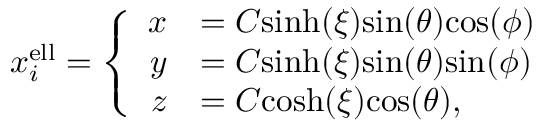Convert formula to latex. <formula><loc_0><loc_0><loc_500><loc_500>\begin{array} { r } { x _ { i } ^ { e l l } = \left \{ \begin{array} { r l } { x } & { = C \sinh ( \xi ) \sin ( \theta ) \cos ( \phi ) } \\ { y } & { = C \sinh ( \xi ) \sin ( \theta ) \sin ( \phi ) } \\ { z } & { = C \cosh ( \xi ) \cos ( \theta ) , } \end{array} } \end{array}</formula> 